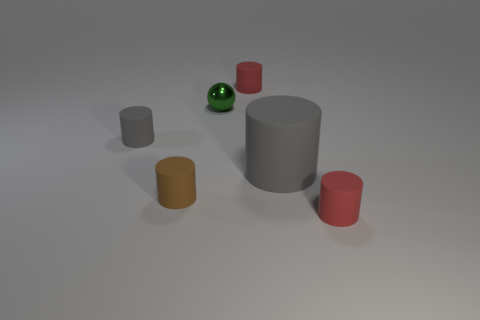Subtract all blue cylinders. Subtract all yellow cubes. How many cylinders are left? 5 Add 3 spheres. How many objects exist? 9 Subtract all balls. How many objects are left? 5 Add 3 small brown rubber things. How many small brown rubber things exist? 4 Subtract 0 green cylinders. How many objects are left? 6 Subtract all small yellow metallic cubes. Subtract all tiny metallic objects. How many objects are left? 5 Add 4 small cylinders. How many small cylinders are left? 8 